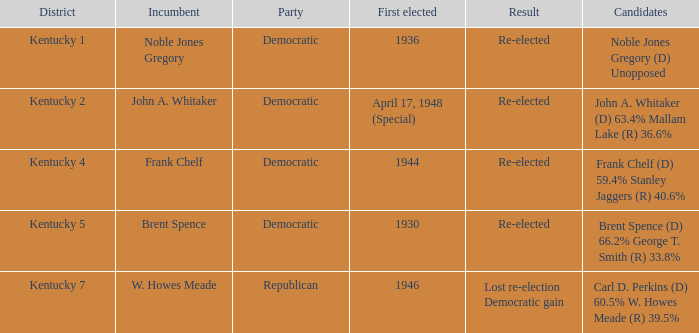What transpired in the voting district kentucky 2? Re-elected. 